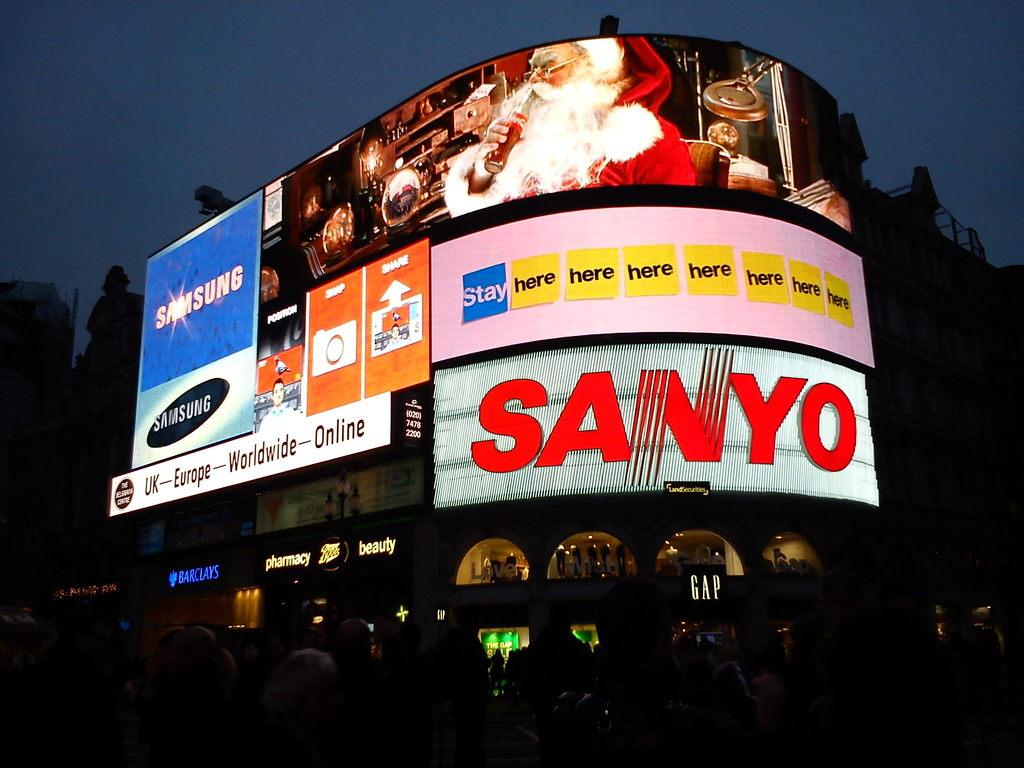<image>
Give a short and clear explanation of the subsequent image. A big advertisement with multiple screens of Santa Claus, Sanyo, Samsung, and a few other ones. 